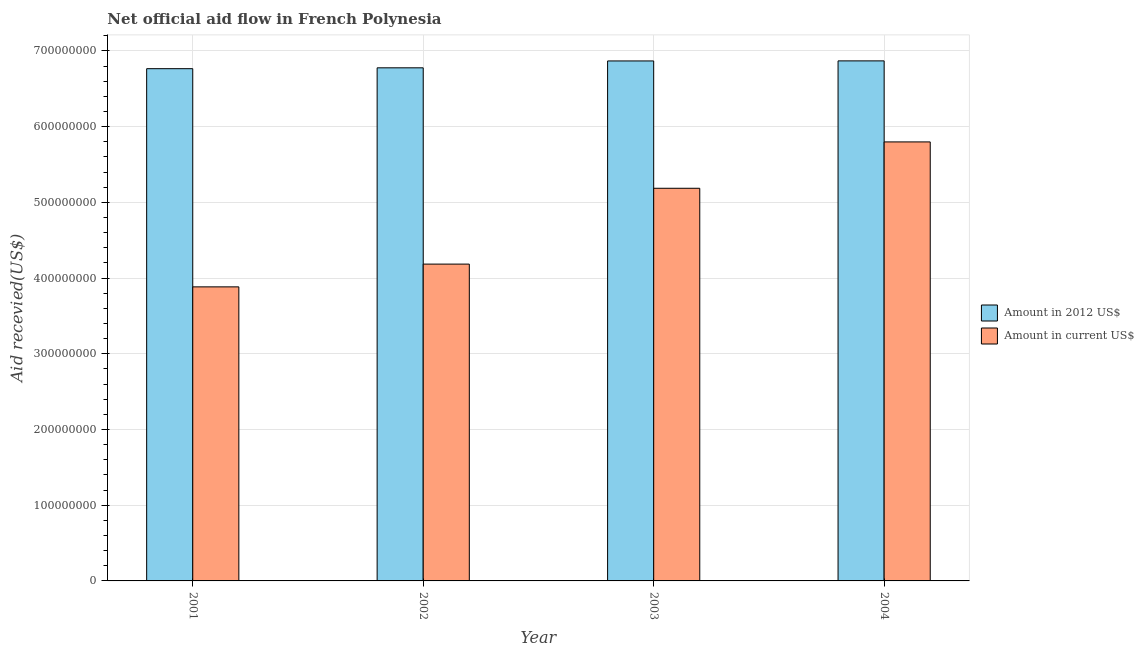Are the number of bars per tick equal to the number of legend labels?
Provide a short and direct response. Yes. Are the number of bars on each tick of the X-axis equal?
Make the answer very short. Yes. How many bars are there on the 2nd tick from the left?
Offer a very short reply. 2. How many bars are there on the 2nd tick from the right?
Ensure brevity in your answer.  2. In how many cases, is the number of bars for a given year not equal to the number of legend labels?
Provide a short and direct response. 0. What is the amount of aid received(expressed in us$) in 2002?
Your answer should be very brief. 4.18e+08. Across all years, what is the maximum amount of aid received(expressed in us$)?
Offer a terse response. 5.80e+08. Across all years, what is the minimum amount of aid received(expressed in us$)?
Offer a terse response. 3.88e+08. In which year was the amount of aid received(expressed in 2012 us$) maximum?
Make the answer very short. 2004. In which year was the amount of aid received(expressed in 2012 us$) minimum?
Your answer should be very brief. 2001. What is the total amount of aid received(expressed in us$) in the graph?
Your response must be concise. 1.91e+09. What is the difference between the amount of aid received(expressed in us$) in 2001 and that in 2003?
Offer a terse response. -1.30e+08. What is the difference between the amount of aid received(expressed in us$) in 2001 and the amount of aid received(expressed in 2012 us$) in 2004?
Give a very brief answer. -1.91e+08. What is the average amount of aid received(expressed in us$) per year?
Ensure brevity in your answer.  4.76e+08. What is the ratio of the amount of aid received(expressed in 2012 us$) in 2001 to that in 2003?
Make the answer very short. 0.99. Is the difference between the amount of aid received(expressed in 2012 us$) in 2002 and 2004 greater than the difference between the amount of aid received(expressed in us$) in 2002 and 2004?
Offer a very short reply. No. What is the difference between the highest and the lowest amount of aid received(expressed in us$)?
Offer a very short reply. 1.91e+08. In how many years, is the amount of aid received(expressed in us$) greater than the average amount of aid received(expressed in us$) taken over all years?
Keep it short and to the point. 2. What does the 2nd bar from the left in 2002 represents?
Your answer should be very brief. Amount in current US$. What does the 1st bar from the right in 2001 represents?
Give a very brief answer. Amount in current US$. Does the graph contain any zero values?
Make the answer very short. No. Does the graph contain grids?
Your response must be concise. Yes. Where does the legend appear in the graph?
Your response must be concise. Center right. How are the legend labels stacked?
Your answer should be very brief. Vertical. What is the title of the graph?
Offer a terse response. Net official aid flow in French Polynesia. Does "Female population" appear as one of the legend labels in the graph?
Give a very brief answer. No. What is the label or title of the X-axis?
Give a very brief answer. Year. What is the label or title of the Y-axis?
Ensure brevity in your answer.  Aid recevied(US$). What is the Aid recevied(US$) of Amount in 2012 US$ in 2001?
Your answer should be very brief. 6.76e+08. What is the Aid recevied(US$) in Amount in current US$ in 2001?
Give a very brief answer. 3.88e+08. What is the Aid recevied(US$) in Amount in 2012 US$ in 2002?
Provide a short and direct response. 6.78e+08. What is the Aid recevied(US$) in Amount in current US$ in 2002?
Make the answer very short. 4.18e+08. What is the Aid recevied(US$) in Amount in 2012 US$ in 2003?
Ensure brevity in your answer.  6.87e+08. What is the Aid recevied(US$) in Amount in current US$ in 2003?
Your answer should be very brief. 5.19e+08. What is the Aid recevied(US$) in Amount in 2012 US$ in 2004?
Your response must be concise. 6.87e+08. What is the Aid recevied(US$) of Amount in current US$ in 2004?
Ensure brevity in your answer.  5.80e+08. Across all years, what is the maximum Aid recevied(US$) of Amount in 2012 US$?
Your answer should be very brief. 6.87e+08. Across all years, what is the maximum Aid recevied(US$) in Amount in current US$?
Offer a very short reply. 5.80e+08. Across all years, what is the minimum Aid recevied(US$) of Amount in 2012 US$?
Your answer should be very brief. 6.76e+08. Across all years, what is the minimum Aid recevied(US$) of Amount in current US$?
Offer a very short reply. 3.88e+08. What is the total Aid recevied(US$) in Amount in 2012 US$ in the graph?
Offer a very short reply. 2.73e+09. What is the total Aid recevied(US$) in Amount in current US$ in the graph?
Provide a short and direct response. 1.91e+09. What is the difference between the Aid recevied(US$) of Amount in 2012 US$ in 2001 and that in 2002?
Give a very brief answer. -1.13e+06. What is the difference between the Aid recevied(US$) of Amount in current US$ in 2001 and that in 2002?
Your response must be concise. -3.01e+07. What is the difference between the Aid recevied(US$) in Amount in 2012 US$ in 2001 and that in 2003?
Provide a succinct answer. -1.02e+07. What is the difference between the Aid recevied(US$) in Amount in current US$ in 2001 and that in 2003?
Your answer should be compact. -1.30e+08. What is the difference between the Aid recevied(US$) in Amount in 2012 US$ in 2001 and that in 2004?
Keep it short and to the point. -1.03e+07. What is the difference between the Aid recevied(US$) of Amount in current US$ in 2001 and that in 2004?
Your answer should be compact. -1.91e+08. What is the difference between the Aid recevied(US$) of Amount in 2012 US$ in 2002 and that in 2003?
Your answer should be compact. -9.07e+06. What is the difference between the Aid recevied(US$) in Amount in current US$ in 2002 and that in 2003?
Offer a terse response. -1.00e+08. What is the difference between the Aid recevied(US$) in Amount in 2012 US$ in 2002 and that in 2004?
Ensure brevity in your answer.  -9.17e+06. What is the difference between the Aid recevied(US$) of Amount in current US$ in 2002 and that in 2004?
Keep it short and to the point. -1.61e+08. What is the difference between the Aid recevied(US$) in Amount in 2012 US$ in 2003 and that in 2004?
Offer a terse response. -1.00e+05. What is the difference between the Aid recevied(US$) in Amount in current US$ in 2003 and that in 2004?
Provide a succinct answer. -6.12e+07. What is the difference between the Aid recevied(US$) in Amount in 2012 US$ in 2001 and the Aid recevied(US$) in Amount in current US$ in 2002?
Your answer should be compact. 2.58e+08. What is the difference between the Aid recevied(US$) of Amount in 2012 US$ in 2001 and the Aid recevied(US$) of Amount in current US$ in 2003?
Your answer should be very brief. 1.58e+08. What is the difference between the Aid recevied(US$) of Amount in 2012 US$ in 2001 and the Aid recevied(US$) of Amount in current US$ in 2004?
Make the answer very short. 9.67e+07. What is the difference between the Aid recevied(US$) in Amount in 2012 US$ in 2002 and the Aid recevied(US$) in Amount in current US$ in 2003?
Offer a terse response. 1.59e+08. What is the difference between the Aid recevied(US$) in Amount in 2012 US$ in 2002 and the Aid recevied(US$) in Amount in current US$ in 2004?
Give a very brief answer. 9.78e+07. What is the difference between the Aid recevied(US$) in Amount in 2012 US$ in 2003 and the Aid recevied(US$) in Amount in current US$ in 2004?
Make the answer very short. 1.07e+08. What is the average Aid recevied(US$) of Amount in 2012 US$ per year?
Keep it short and to the point. 6.82e+08. What is the average Aid recevied(US$) of Amount in current US$ per year?
Offer a terse response. 4.76e+08. In the year 2001, what is the difference between the Aid recevied(US$) of Amount in 2012 US$ and Aid recevied(US$) of Amount in current US$?
Provide a succinct answer. 2.88e+08. In the year 2002, what is the difference between the Aid recevied(US$) of Amount in 2012 US$ and Aid recevied(US$) of Amount in current US$?
Offer a terse response. 2.59e+08. In the year 2003, what is the difference between the Aid recevied(US$) in Amount in 2012 US$ and Aid recevied(US$) in Amount in current US$?
Your answer should be very brief. 1.68e+08. In the year 2004, what is the difference between the Aid recevied(US$) in Amount in 2012 US$ and Aid recevied(US$) in Amount in current US$?
Your answer should be very brief. 1.07e+08. What is the ratio of the Aid recevied(US$) in Amount in current US$ in 2001 to that in 2002?
Ensure brevity in your answer.  0.93. What is the ratio of the Aid recevied(US$) of Amount in 2012 US$ in 2001 to that in 2003?
Your response must be concise. 0.99. What is the ratio of the Aid recevied(US$) of Amount in current US$ in 2001 to that in 2003?
Make the answer very short. 0.75. What is the ratio of the Aid recevied(US$) in Amount in current US$ in 2001 to that in 2004?
Ensure brevity in your answer.  0.67. What is the ratio of the Aid recevied(US$) in Amount in current US$ in 2002 to that in 2003?
Your answer should be very brief. 0.81. What is the ratio of the Aid recevied(US$) of Amount in 2012 US$ in 2002 to that in 2004?
Provide a succinct answer. 0.99. What is the ratio of the Aid recevied(US$) of Amount in current US$ in 2002 to that in 2004?
Your answer should be very brief. 0.72. What is the ratio of the Aid recevied(US$) of Amount in 2012 US$ in 2003 to that in 2004?
Offer a very short reply. 1. What is the ratio of the Aid recevied(US$) of Amount in current US$ in 2003 to that in 2004?
Give a very brief answer. 0.89. What is the difference between the highest and the second highest Aid recevied(US$) in Amount in current US$?
Provide a succinct answer. 6.12e+07. What is the difference between the highest and the lowest Aid recevied(US$) in Amount in 2012 US$?
Offer a very short reply. 1.03e+07. What is the difference between the highest and the lowest Aid recevied(US$) of Amount in current US$?
Provide a short and direct response. 1.91e+08. 